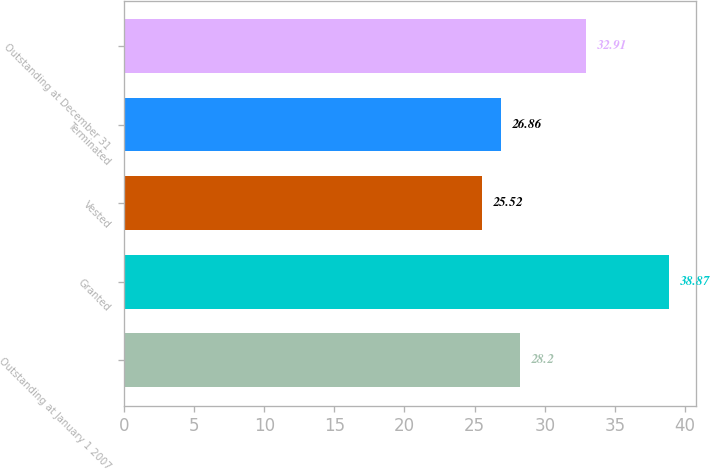<chart> <loc_0><loc_0><loc_500><loc_500><bar_chart><fcel>Outstanding at January 1 2007<fcel>Granted<fcel>Vested<fcel>Terminated<fcel>Outstanding at December 31<nl><fcel>28.2<fcel>38.87<fcel>25.52<fcel>26.86<fcel>32.91<nl></chart> 